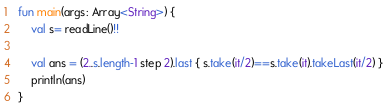Convert code to text. <code><loc_0><loc_0><loc_500><loc_500><_Kotlin_>fun main(args: Array<String>) {
    val s= readLine()!!

    val ans = (2..s.length-1 step 2).last { s.take(it/2)==s.take(it).takeLast(it/2) }
    println(ans)
}</code> 